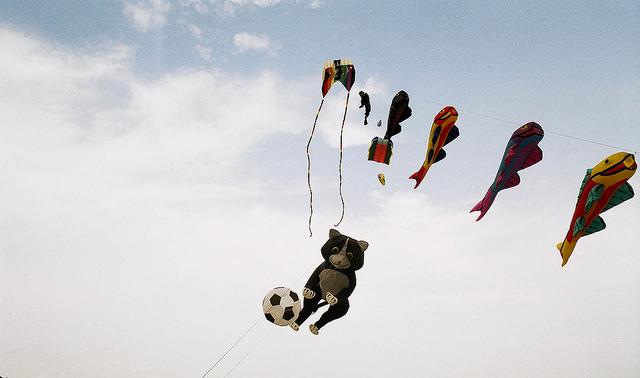How many kites are in the air?
Answer briefly. 8. Are the kites attached to each other?
Be succinct. Yes. What are these objects in the sky?
Be succinct. Kites. Is there a basketball?
Quick response, please. No. How many cables are in front of the man?
Quick response, please. 3. 